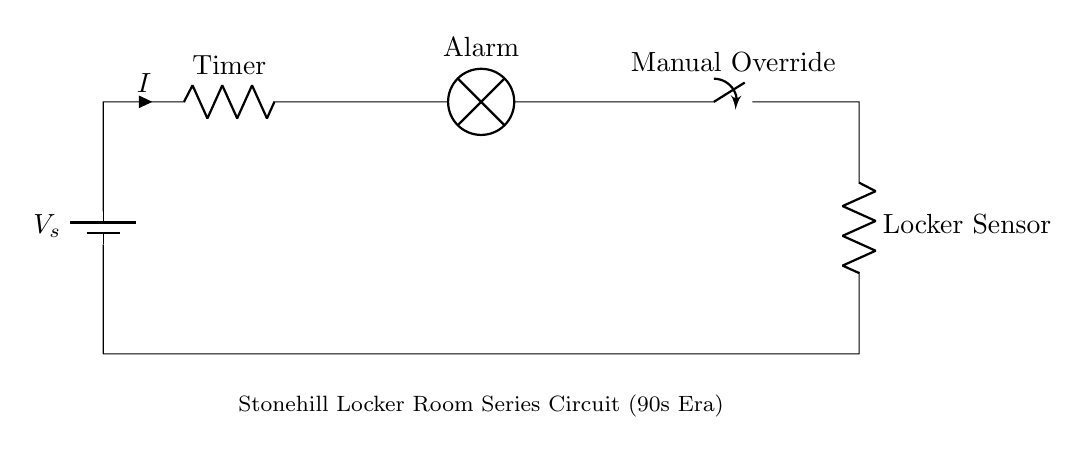What is the main power source in this circuit? The power source is a battery, depicted as a battery symbol labeled with V_s.
Answer: Battery What does the timer represent in this circuit? The timer is represented as a resistor labeled "Timer" which indicates that it controls the time for the circuit operation.
Answer: Timer How many total components are in this circuit? The circuit has five components: one battery, one timer, one lamp, one switch, and one locker sensor resistor.
Answer: Five Which component indicates the manual control aspect of the circuit? The switch labeled "Manual Override" indicates that the user can manually control the circuit.
Answer: Manual Override What is the purpose of the lamp in this series circuit? The lamp labeled "Alarm" serves as a visual indicator for the alarm function when the circuit is active.
Answer: Alarm If the timer has a resistance of ten ohms and the battery is supplying twelve volts, what is the current passing through the circuit? Using Ohm's law (I = V/R), the current can be calculated as I = 12V / 10Ω, which equals 1.2A.
Answer: 1.2A What happens to the circuit if the manual override switch is turned off? If the manual override switch is turned off, the circuit would stop operating, and the alarm would not activate.
Answer: No operation 